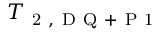Convert formula to latex. <formula><loc_0><loc_0><loc_500><loc_500>T _ { 2 , D Q + P 1 }</formula> 